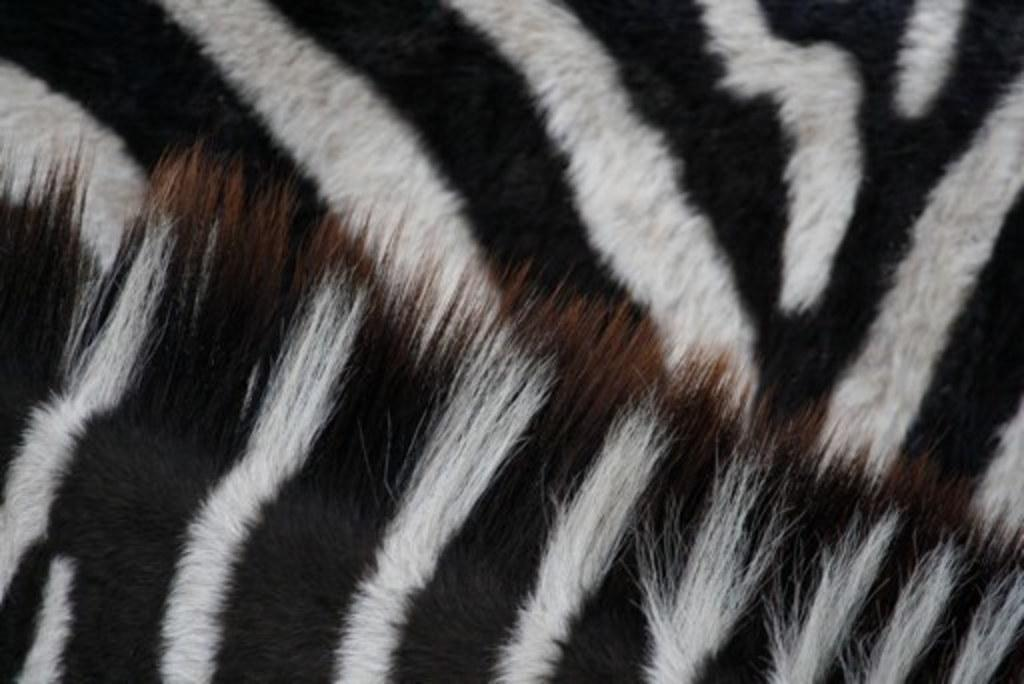What is the main subject of the image? The main subject of the image is a close-up view of a zebra's hair. Where is the hair located on the zebra? The hair is present on the skin of the zebra. What type of underwear is the zebra wearing in the image? There is no underwear present in the image, as it is a close-up view of a zebra's hair on its skin. 